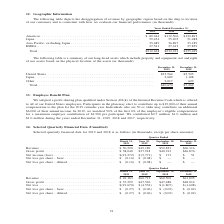According to A10 Networks's financial document, What kind of asset data is described in the table? long-lived assets which include property and equipment, net and right of use assets based on the physical location of the assets. The document states: "The following table is a summary of our long-lived assets which include property and equipment, net and right of use assets based on the physical loca..." Also, What is the units used to describe the data in the table? According to the financial document, thousands. The relevant text states: "ith how we evaluate our financial performance (in thousands):..." Also, Which countries' data have been singled out in the table? The document shows two values: United States and Japan. From the document: "United States. . $35,964 $5,525 Japan . 2,689 1,108 Other . 2,017 629 United States. . $35,964 $5,525 Japan . 2,689 1,108 Other . 2,017 629..." Also, can you calculate: What is the total amount of long-lived asset in Japan in both 2018 and 2019? Based on the calculation: 2,689+1,108, the result is 3797 (in thousands). This is based on the information: "United States. . $35,964 $5,525 Japan . 2,689 1,108 Other . 2,017 629 United States. . $35,964 $5,525 Japan . 2,689 1,108 Other . 2,017 629..." The key data points involved are: 1,108, 2,689. Also, can you calculate: What is the percentage change in value between long-lived assets in the U.S. in 2018 and 2019? To answer this question, I need to perform calculations using the financial data. The calculation is: ($35,964 - $5,525)/$5,525 , which equals 550.93 (percentage). This is based on the information: "United States. . $35,964 $5,525 Japan . 2,689 1,108 Other . 2,017 629 United States. . $35,964 $5,525 Japan . 2,689 1,108 Other . 2,017 629..." The key data points involved are: 35,964, 5,525. Also, can you calculate: What is the total value of long-lived assets in the U.S. and Japan in 2019? Based on the calculation: $35,964+2,689, the result is 38653 (in thousands). This is based on the information: "United States. . $35,964 $5,525 Japan . 2,689 1,108 Other . 2,017 629 United States. . $35,964 $5,525 Japan . 2,689 1,108 Other . 2,017 629..." The key data points involved are: 2,689, 35,964. 